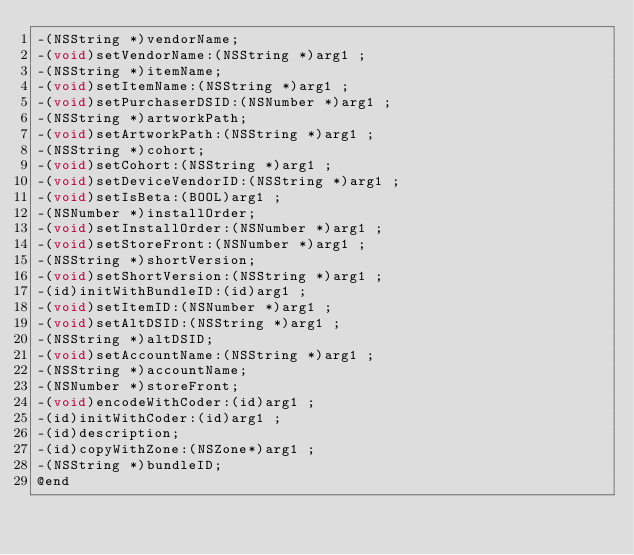Convert code to text. <code><loc_0><loc_0><loc_500><loc_500><_C_>-(NSString *)vendorName;
-(void)setVendorName:(NSString *)arg1 ;
-(NSString *)itemName;
-(void)setItemName:(NSString *)arg1 ;
-(void)setPurchaserDSID:(NSNumber *)arg1 ;
-(NSString *)artworkPath;
-(void)setArtworkPath:(NSString *)arg1 ;
-(NSString *)cohort;
-(void)setCohort:(NSString *)arg1 ;
-(void)setDeviceVendorID:(NSString *)arg1 ;
-(void)setIsBeta:(BOOL)arg1 ;
-(NSNumber *)installOrder;
-(void)setInstallOrder:(NSNumber *)arg1 ;
-(void)setStoreFront:(NSNumber *)arg1 ;
-(NSString *)shortVersion;
-(void)setShortVersion:(NSString *)arg1 ;
-(id)initWithBundleID:(id)arg1 ;
-(void)setItemID:(NSNumber *)arg1 ;
-(void)setAltDSID:(NSString *)arg1 ;
-(NSString *)altDSID;
-(void)setAccountName:(NSString *)arg1 ;
-(NSString *)accountName;
-(NSNumber *)storeFront;
-(void)encodeWithCoder:(id)arg1 ;
-(id)initWithCoder:(id)arg1 ;
-(id)description;
-(id)copyWithZone:(NSZone*)arg1 ;
-(NSString *)bundleID;
@end

</code> 